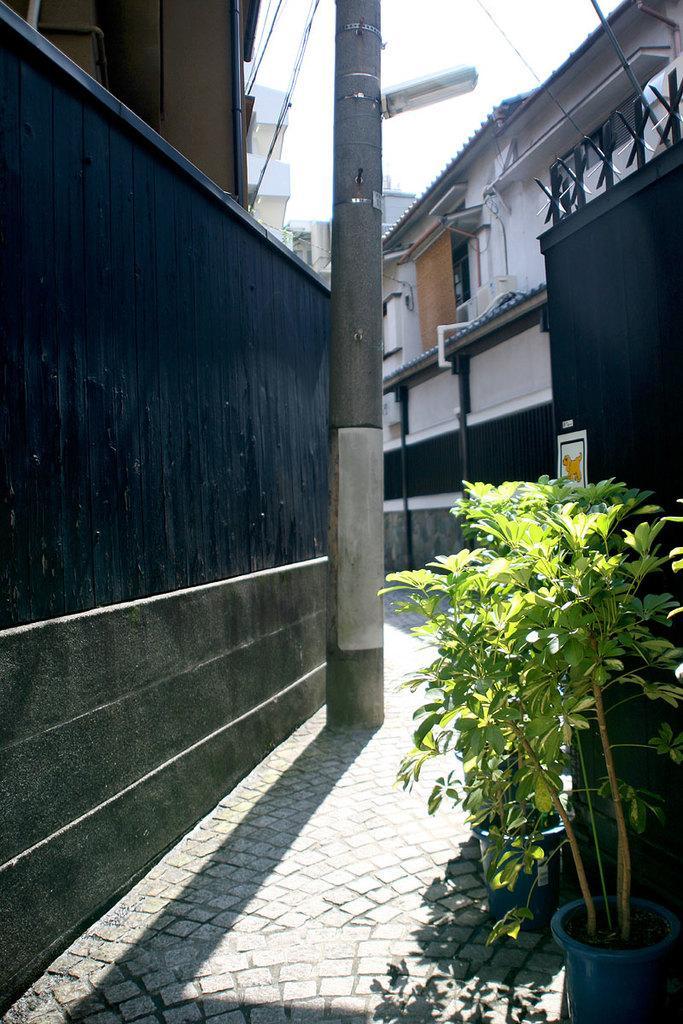Could you give a brief overview of what you see in this image? These are buildings, this is plant. 